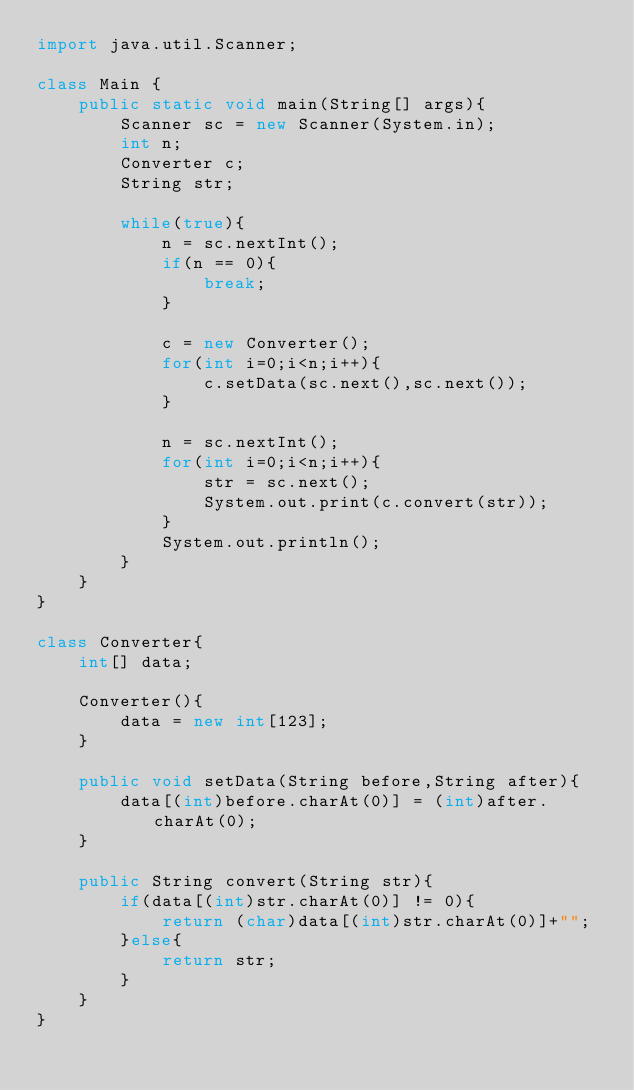Convert code to text. <code><loc_0><loc_0><loc_500><loc_500><_Java_>import java.util.Scanner;

class Main {
	public static void main(String[] args){
		Scanner sc = new Scanner(System.in);
		int n;
		Converter c;
		String str;

		while(true){
			n = sc.nextInt();
			if(n == 0){
				break;
			}

			c = new Converter();
			for(int i=0;i<n;i++){
				c.setData(sc.next(),sc.next());
			}

			n = sc.nextInt();
			for(int i=0;i<n;i++){
				str = sc.next();
				System.out.print(c.convert(str));
			}
			System.out.println();
		}
	}
}

class Converter{
	int[] data;

	Converter(){
		data = new int[123];
	}

	public void setData(String before,String after){
		data[(int)before.charAt(0)] = (int)after.charAt(0);
	}

	public String convert(String str){
		if(data[(int)str.charAt(0)] != 0){
			return (char)data[(int)str.charAt(0)]+"";
		}else{
			return str;
		}
	}
}</code> 